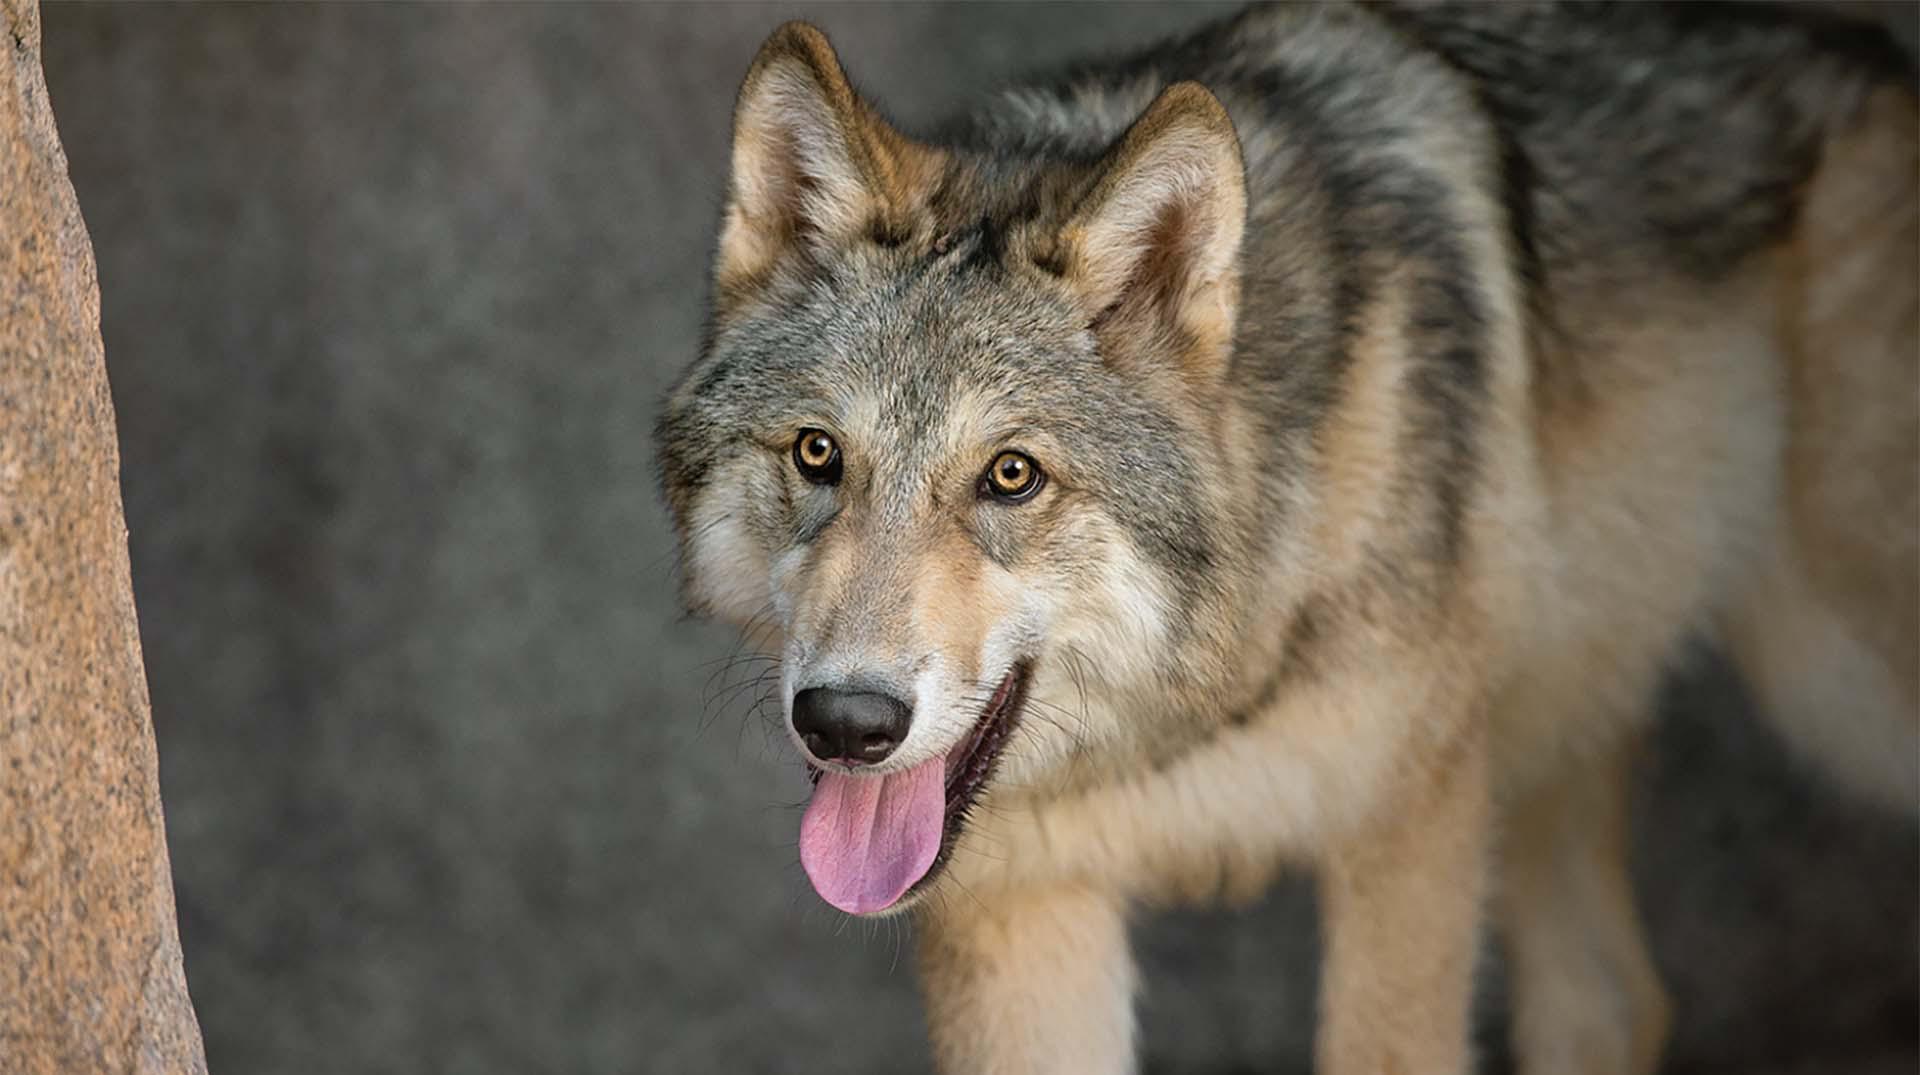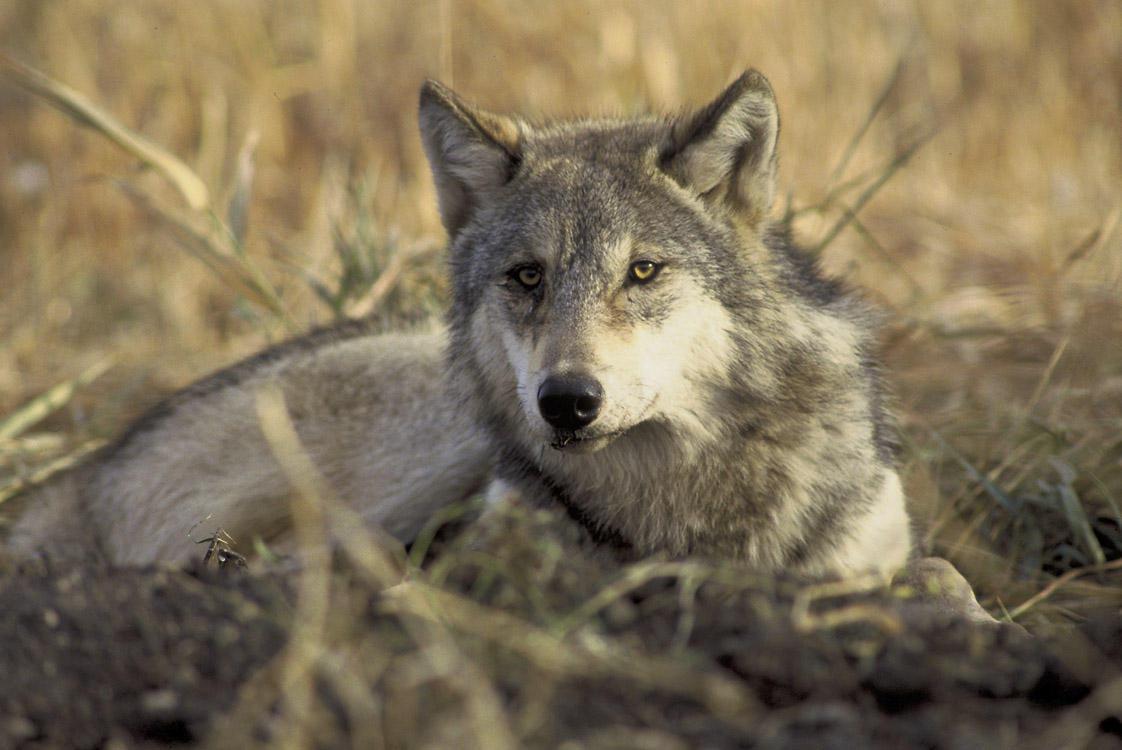The first image is the image on the left, the second image is the image on the right. Analyze the images presented: Is the assertion "there are two wolves standing close together" valid? Answer yes or no. No. The first image is the image on the left, the second image is the image on the right. Given the left and right images, does the statement "One image shows two wolves with their faces side-by-side, and the other image features one forward-looking wolf." hold true? Answer yes or no. No. 